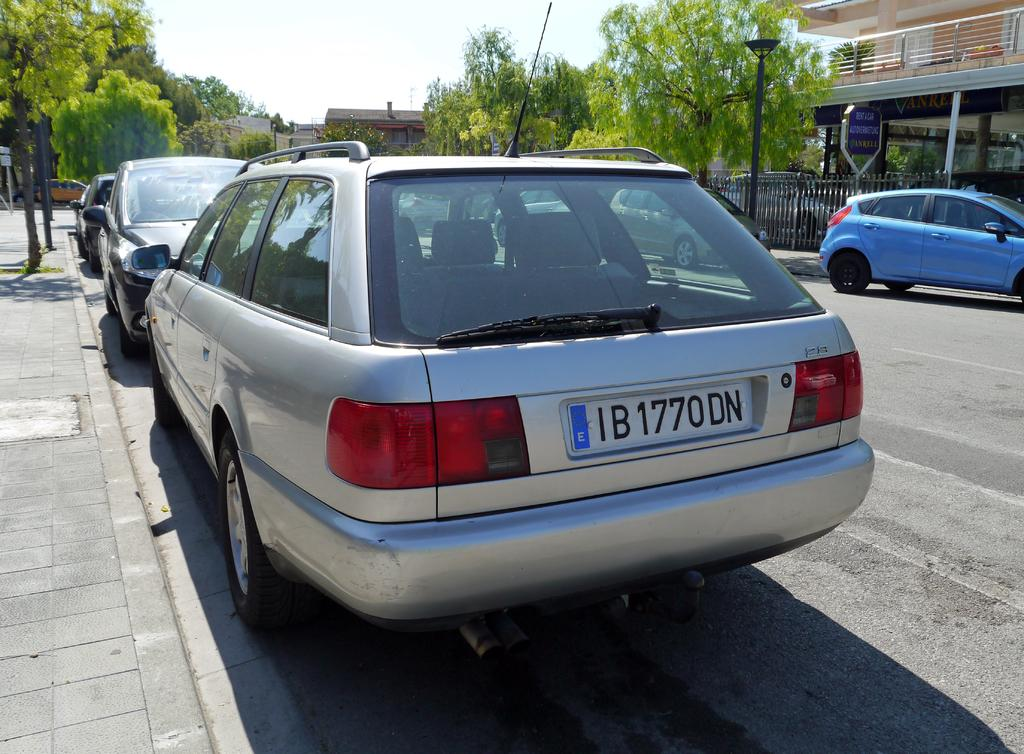<image>
Give a short and clear explanation of the subsequent image. The silver station wagon's license plate is IB1770DN. 